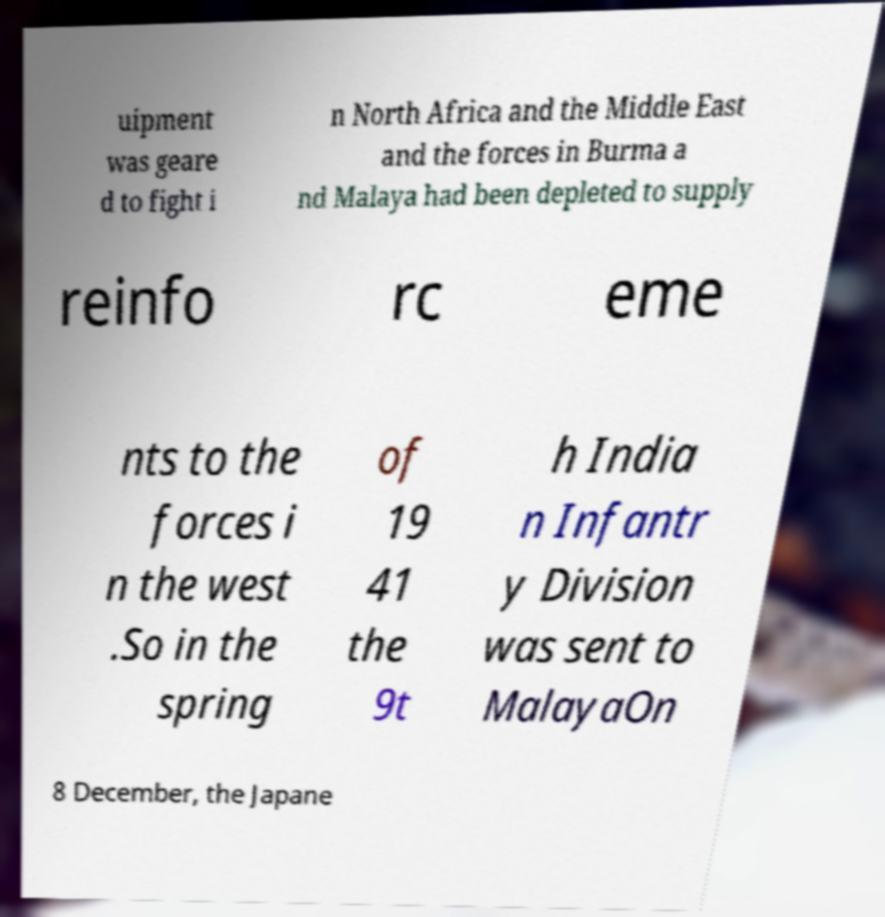What messages or text are displayed in this image? I need them in a readable, typed format. uipment was geare d to fight i n North Africa and the Middle East and the forces in Burma a nd Malaya had been depleted to supply reinfo rc eme nts to the forces i n the west .So in the spring of 19 41 the 9t h India n Infantr y Division was sent to MalayaOn 8 December, the Japane 